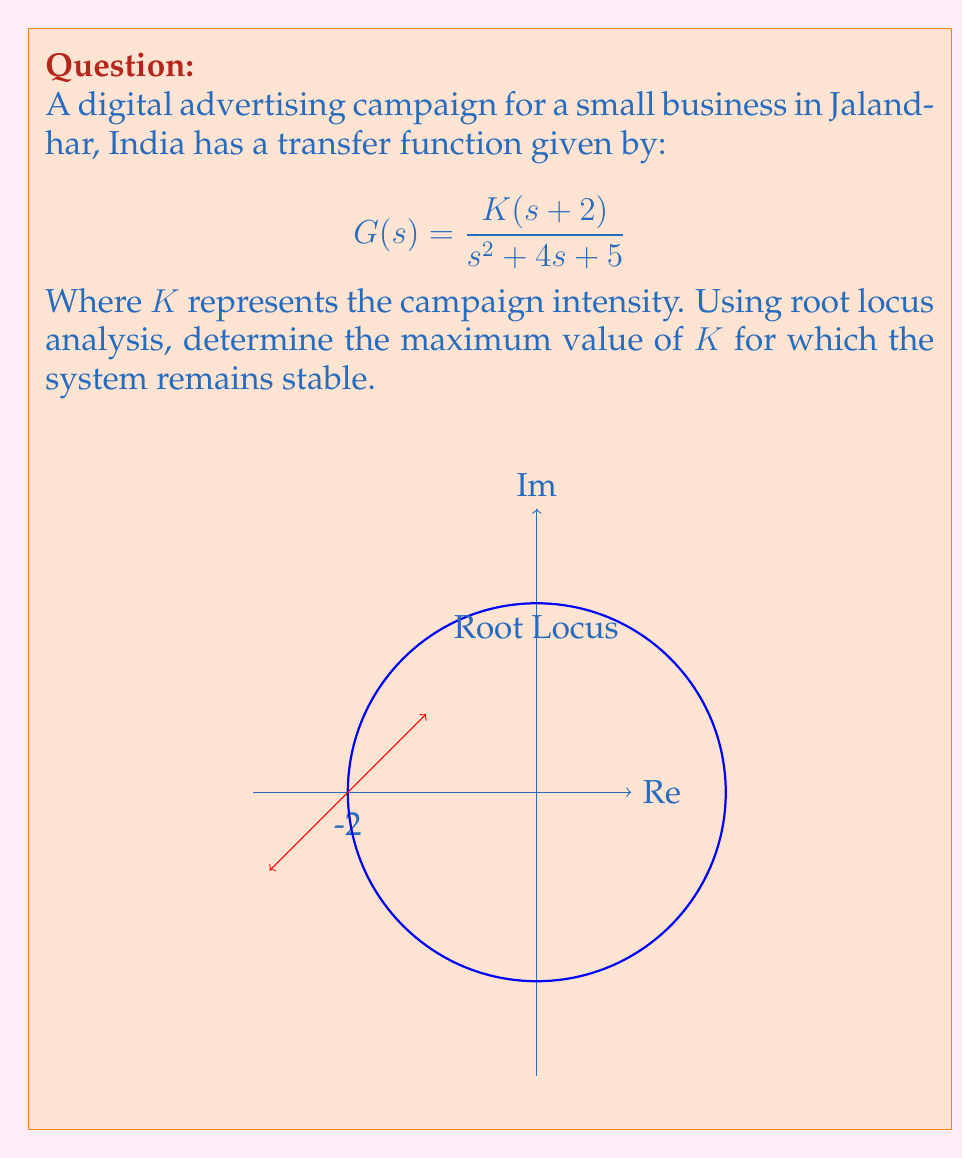Teach me how to tackle this problem. To determine the stability of the system using root locus analysis, we need to follow these steps:

1) First, identify the open-loop poles and zeros:
   Poles: $s^2 + 4s + 5 = 0$ 
   $s = -2 \pm j$
   Zero: $s = -2$

2) The root locus starts at the open-loop poles and ends at the open-loop zeros or infinity.

3) The system becomes unstable when the root locus crosses the imaginary axis. We need to find the value of $K$ at this point.

4) At the imaginary axis crossing, $s = j\omega$. Substituting this into the characteristic equation:

   $$1 + KG(s) = 0$$
   $$1 + K\frac{(j\omega+2)}{(j\omega)^2 + 4(j\omega) + 5} = 0$$

5) Separating real and imaginary parts:

   Real: $1 + K\frac{2(5-\omega^2)}{(5-\omega^2)^2 + (4\omega)^2} = 0$
   
   Imaginary: $K\frac{\omega(9-\omega^2)}{(5-\omega^2)^2 + (4\omega)^2} = 0$

6) From the imaginary part, we get $\omega = 3$ (since $\omega = 0$ is not on the imaginary axis).

7) Substituting $\omega = 3$ into the real part:

   $$1 + K\frac{2(-4)}{(-4)^2 + (12)^2} = 0$$

8) Solving for $K$:

   $$K = \frac{160}{8} = 20$$

Therefore, the system remains stable for $0 < K < 20$.
Answer: $K_{max} = 20$ 